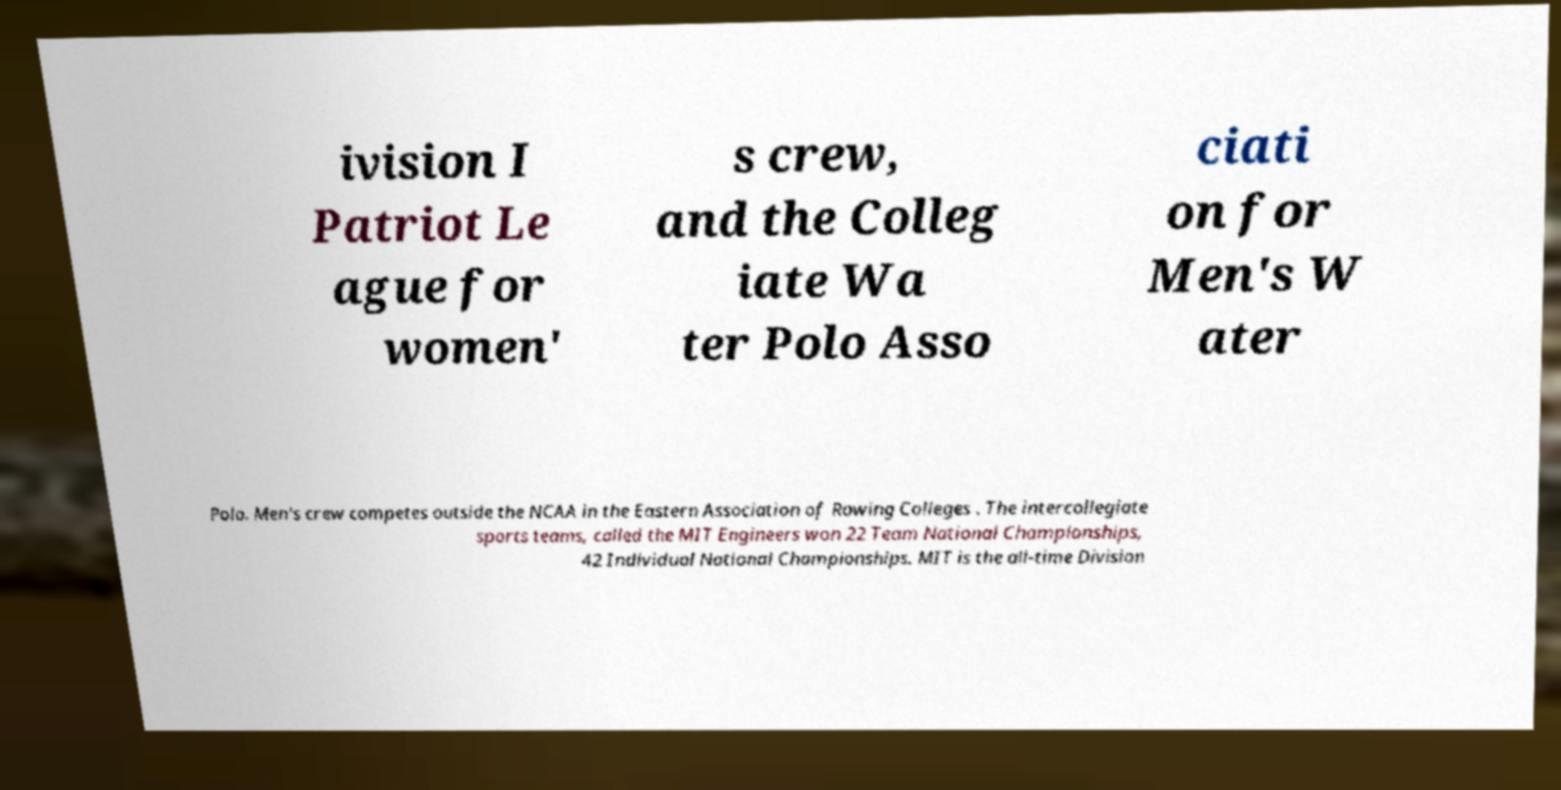Can you read and provide the text displayed in the image?This photo seems to have some interesting text. Can you extract and type it out for me? ivision I Patriot Le ague for women' s crew, and the Colleg iate Wa ter Polo Asso ciati on for Men's W ater Polo. Men's crew competes outside the NCAA in the Eastern Association of Rowing Colleges . The intercollegiate sports teams, called the MIT Engineers won 22 Team National Championships, 42 Individual National Championships. MIT is the all-time Division 